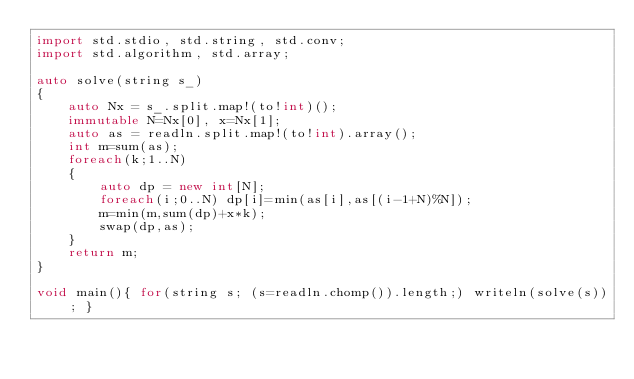<code> <loc_0><loc_0><loc_500><loc_500><_D_>import std.stdio, std.string, std.conv;
import std.algorithm, std.array;
 
auto solve(string s_)
{
    auto Nx = s_.split.map!(to!int)();
    immutable N=Nx[0], x=Nx[1];
    auto as = readln.split.map!(to!int).array();
    int m=sum(as);
    foreach(k;1..N)
    {
        auto dp = new int[N];
        foreach(i;0..N) dp[i]=min(as[i],as[(i-1+N)%N]);
        m=min(m,sum(dp)+x*k);
        swap(dp,as);
    }
    return m;
}

void main(){ for(string s; (s=readln.chomp()).length;) writeln(solve(s)); }</code> 